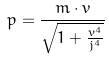Convert formula to latex. <formula><loc_0><loc_0><loc_500><loc_500>p = \frac { m \cdot v } { \sqrt { 1 + \frac { v ^ { 4 } } { j ^ { 4 } } } }</formula> 